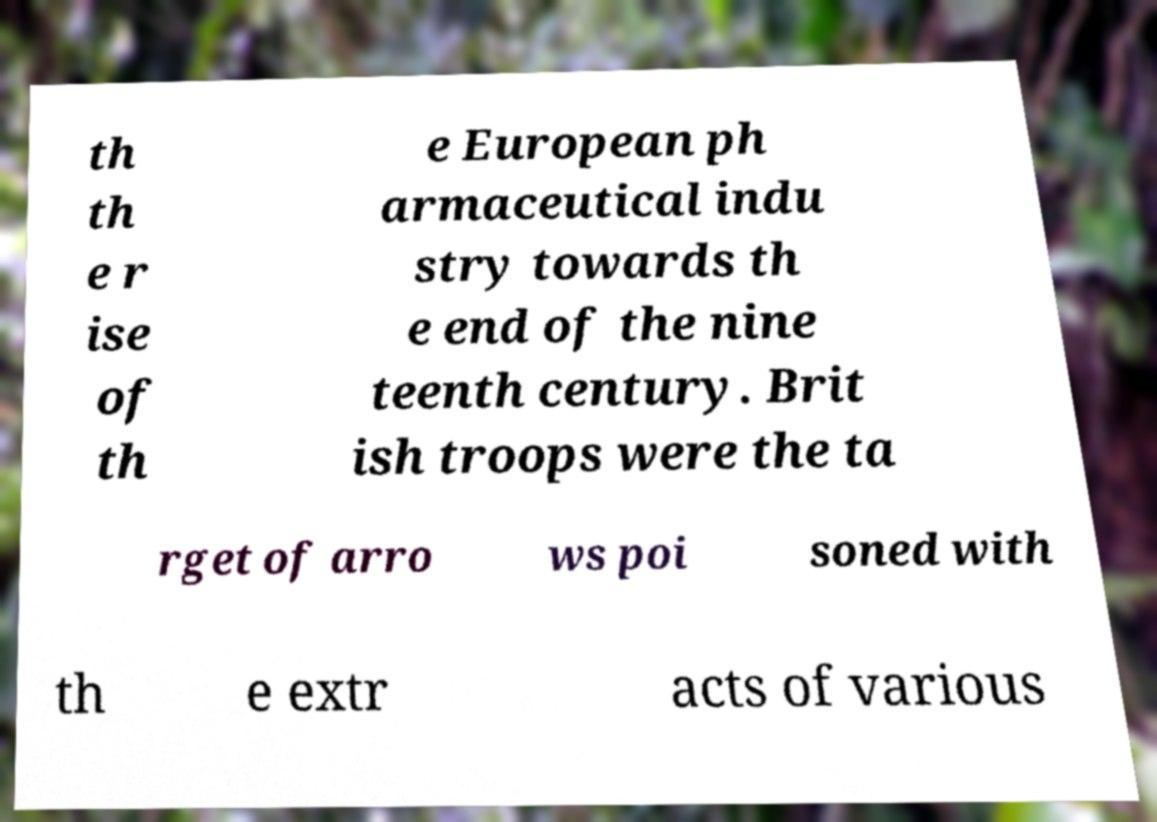Could you extract and type out the text from this image? th th e r ise of th e European ph armaceutical indu stry towards th e end of the nine teenth century. Brit ish troops were the ta rget of arro ws poi soned with th e extr acts of various 